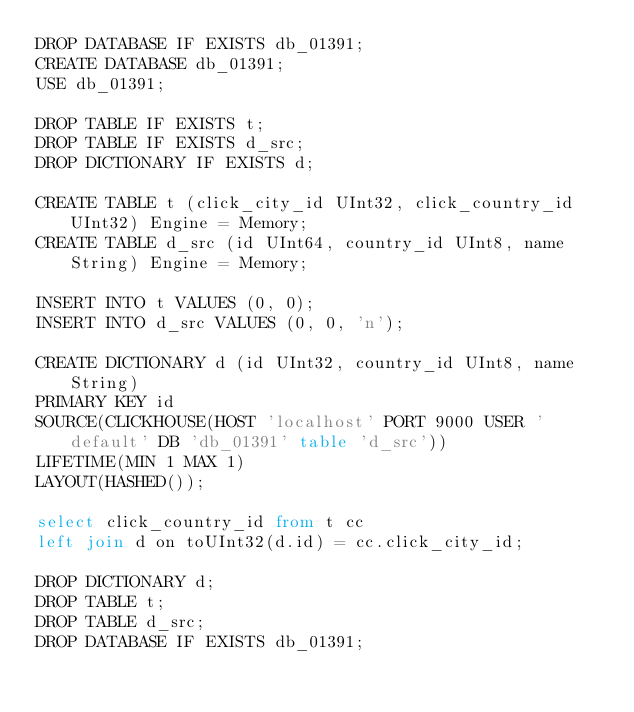<code> <loc_0><loc_0><loc_500><loc_500><_SQL_>DROP DATABASE IF EXISTS db_01391;
CREATE DATABASE db_01391;
USE db_01391;

DROP TABLE IF EXISTS t;
DROP TABLE IF EXISTS d_src;
DROP DICTIONARY IF EXISTS d;

CREATE TABLE t (click_city_id UInt32, click_country_id UInt32) Engine = Memory;
CREATE TABLE d_src (id UInt64, country_id UInt8, name String) Engine = Memory;

INSERT INTO t VALUES (0, 0);
INSERT INTO d_src VALUES (0, 0, 'n');

CREATE DICTIONARY d (id UInt32, country_id UInt8, name String)
PRIMARY KEY id
SOURCE(CLICKHOUSE(HOST 'localhost' PORT 9000 USER 'default' DB 'db_01391' table 'd_src'))
LIFETIME(MIN 1 MAX 1)
LAYOUT(HASHED());

select click_country_id from t cc
left join d on toUInt32(d.id) = cc.click_city_id;

DROP DICTIONARY d;
DROP TABLE t;
DROP TABLE d_src;
DROP DATABASE IF EXISTS db_01391;
</code> 